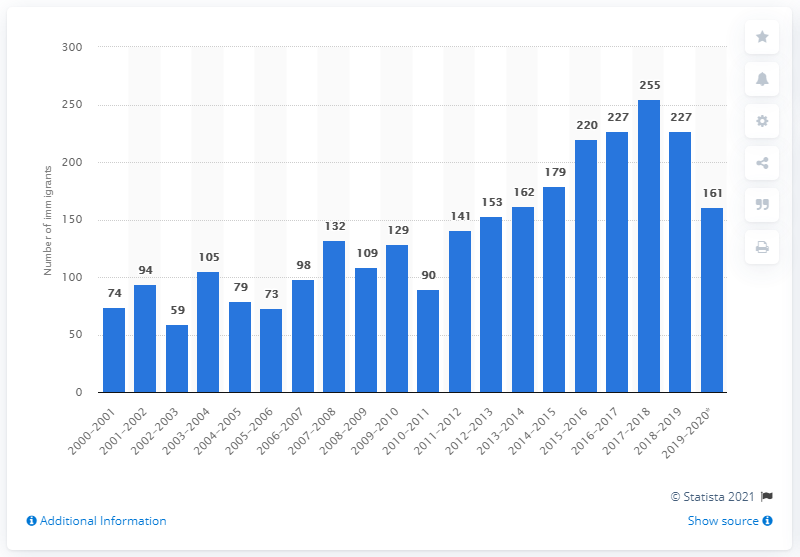Identify some key points in this picture. During the 2019-2020 fiscal year, a total of 161 new immigrants arrived in the Northwest Territories. 